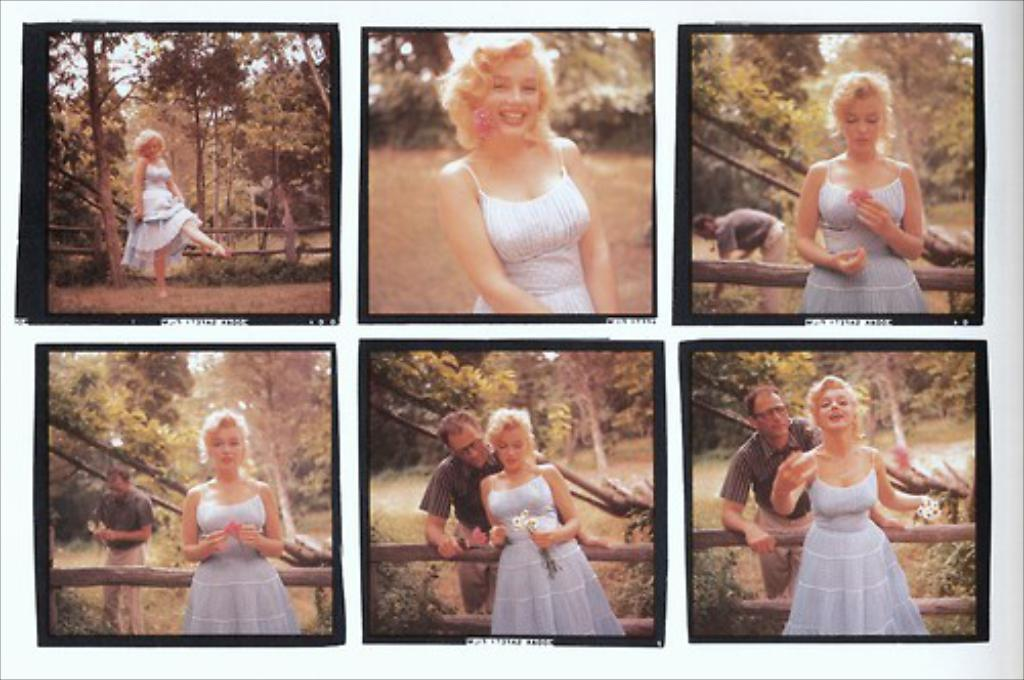What type of image is being described? The image is a collage of different pictures. How many people are present in the first three pictures? In the first three pictures, there is only one person present. How many people are present in the last three pictures? In the last three pictures, there are two persons present. What type of insurance policy is being discussed in the image? There is no mention of insurance in the image, as it is a collage of different pictures. Can you tell me what class the rabbit is taking in the image? There is no rabbit present in the image, so it is not possible to determine what class it might be taking. 